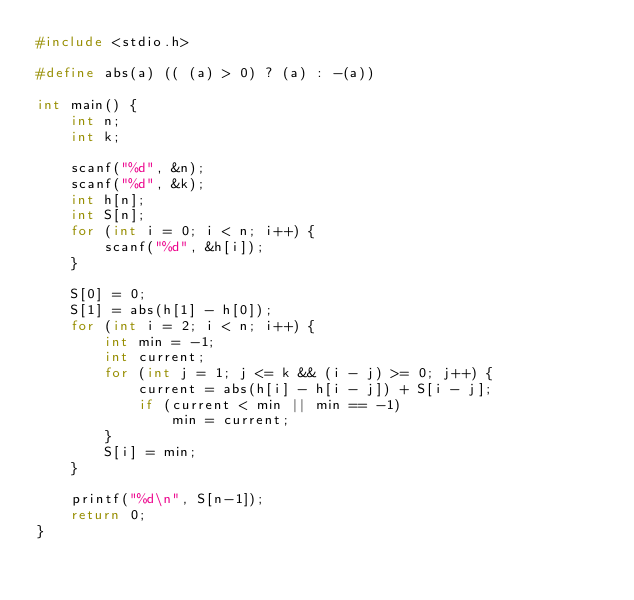<code> <loc_0><loc_0><loc_500><loc_500><_C_>#include <stdio.h>

#define abs(a) (( (a) > 0) ? (a) : -(a))

int main() {
    int n;
    int k;

    scanf("%d", &n);
    scanf("%d", &k);
    int h[n];
    int S[n];
    for (int i = 0; i < n; i++) {
        scanf("%d", &h[i]);
    }

    S[0] = 0;
    S[1] = abs(h[1] - h[0]);
  	for (int i = 2; i < n; i++) {
        int min = -1;
        int current;
        for (int j = 1; j <= k && (i - j) >= 0; j++) {
            current = abs(h[i] - h[i - j]) + S[i - j];
            if (current < min || min == -1)
                min = current;
        }
        S[i] = min;
    }

    printf("%d\n", S[n-1]);
    return 0;
}
</code> 